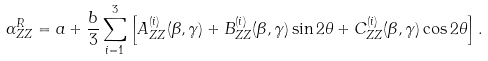<formula> <loc_0><loc_0><loc_500><loc_500>\alpha _ { Z Z } ^ { R } = a + \frac { b } { 3 } \sum _ { i = 1 } ^ { 3 } \left [ A _ { Z Z } ^ { ( i ) } ( \beta , \gamma ) + B _ { Z Z } ^ { ( i ) } ( \beta , \gamma ) \sin 2 \theta + C _ { Z Z } ^ { ( i ) } ( \beta , \gamma ) \cos 2 \theta \right ] .</formula> 